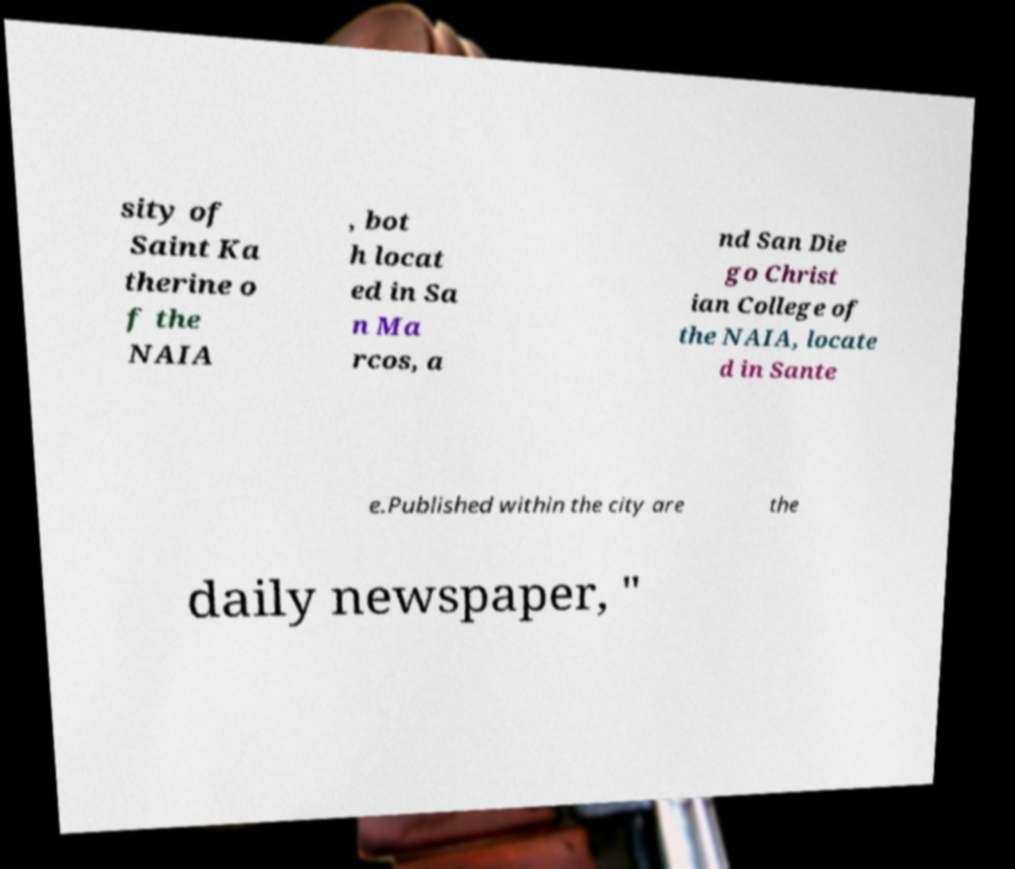Could you assist in decoding the text presented in this image and type it out clearly? sity of Saint Ka therine o f the NAIA , bot h locat ed in Sa n Ma rcos, a nd San Die go Christ ian College of the NAIA, locate d in Sante e.Published within the city are the daily newspaper, " 